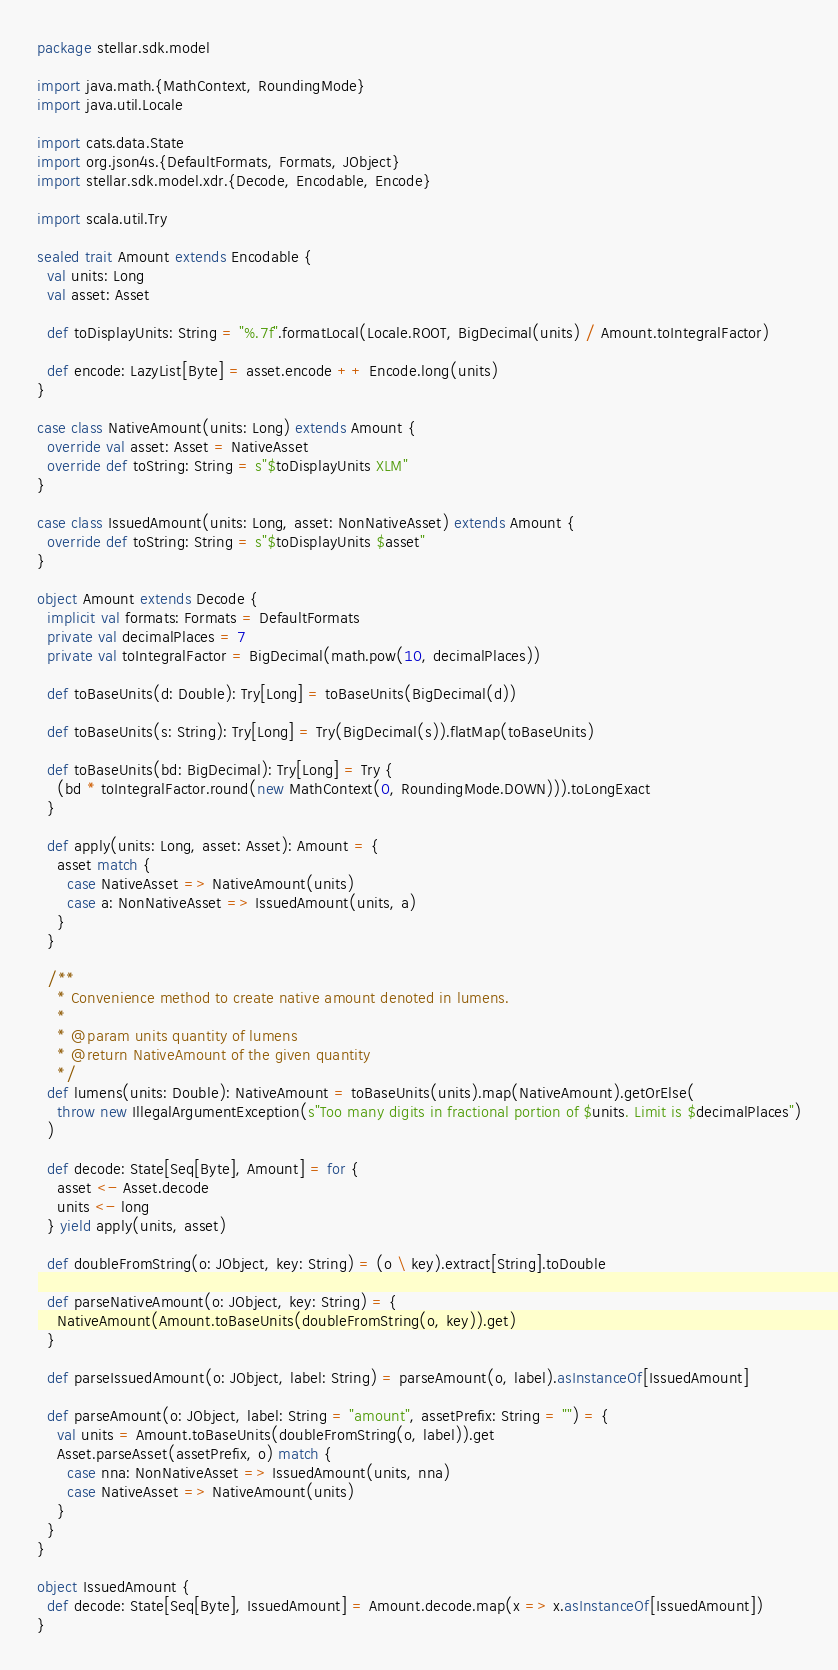<code> <loc_0><loc_0><loc_500><loc_500><_Scala_>package stellar.sdk.model

import java.math.{MathContext, RoundingMode}
import java.util.Locale

import cats.data.State
import org.json4s.{DefaultFormats, Formats, JObject}
import stellar.sdk.model.xdr.{Decode, Encodable, Encode}

import scala.util.Try

sealed trait Amount extends Encodable {
  val units: Long
  val asset: Asset

  def toDisplayUnits: String = "%.7f".formatLocal(Locale.ROOT, BigDecimal(units) / Amount.toIntegralFactor)

  def encode: LazyList[Byte] = asset.encode ++ Encode.long(units)
}

case class NativeAmount(units: Long) extends Amount {
  override val asset: Asset = NativeAsset
  override def toString: String = s"$toDisplayUnits XLM"
}

case class IssuedAmount(units: Long, asset: NonNativeAsset) extends Amount {
  override def toString: String = s"$toDisplayUnits $asset"
}

object Amount extends Decode {
  implicit val formats: Formats = DefaultFormats
  private val decimalPlaces = 7
  private val toIntegralFactor = BigDecimal(math.pow(10, decimalPlaces))

  def toBaseUnits(d: Double): Try[Long] = toBaseUnits(BigDecimal(d))

  def toBaseUnits(s: String): Try[Long] = Try(BigDecimal(s)).flatMap(toBaseUnits)

  def toBaseUnits(bd: BigDecimal): Try[Long] = Try {
    (bd * toIntegralFactor.round(new MathContext(0, RoundingMode.DOWN))).toLongExact
  }

  def apply(units: Long, asset: Asset): Amount = {
    asset match {
      case NativeAsset => NativeAmount(units)
      case a: NonNativeAsset => IssuedAmount(units, a)
    }
  }

  /**
    * Convenience method to create native amount denoted in lumens.
    *
    * @param units quantity of lumens
    * @return NativeAmount of the given quantity
    */
  def lumens(units: Double): NativeAmount = toBaseUnits(units).map(NativeAmount).getOrElse(
    throw new IllegalArgumentException(s"Too many digits in fractional portion of $units. Limit is $decimalPlaces")
  )

  def decode: State[Seq[Byte], Amount] = for {
    asset <- Asset.decode
    units <- long
  } yield apply(units, asset)

  def doubleFromString(o: JObject, key: String) = (o \ key).extract[String].toDouble

  def parseNativeAmount(o: JObject, key: String) = {
    NativeAmount(Amount.toBaseUnits(doubleFromString(o, key)).get)
  }

  def parseIssuedAmount(o: JObject, label: String) = parseAmount(o, label).asInstanceOf[IssuedAmount]

  def parseAmount(o: JObject, label: String = "amount", assetPrefix: String = "") = {
    val units = Amount.toBaseUnits(doubleFromString(o, label)).get
    Asset.parseAsset(assetPrefix, o) match {
      case nna: NonNativeAsset => IssuedAmount(units, nna)
      case NativeAsset => NativeAmount(units)
    }
  }
}

object IssuedAmount {
  def decode: State[Seq[Byte], IssuedAmount] = Amount.decode.map(x => x.asInstanceOf[IssuedAmount])
}</code> 